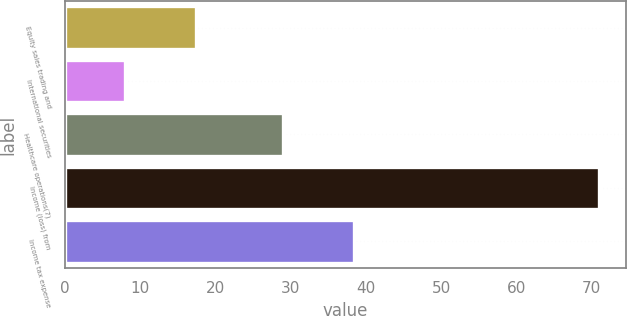Convert chart to OTSL. <chart><loc_0><loc_0><loc_500><loc_500><bar_chart><fcel>Equity sales trading and<fcel>International securities<fcel>Healthcare operations(7)<fcel>Income (loss) from<fcel>Income tax expense<nl><fcel>17.4<fcel>8<fcel>29<fcel>71<fcel>38.4<nl></chart> 